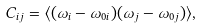Convert formula to latex. <formula><loc_0><loc_0><loc_500><loc_500>C _ { i j } = \langle ( \omega _ { i } - \omega _ { 0 i } ) ( \omega _ { j } - \omega _ { 0 j } ) \rangle ,</formula> 